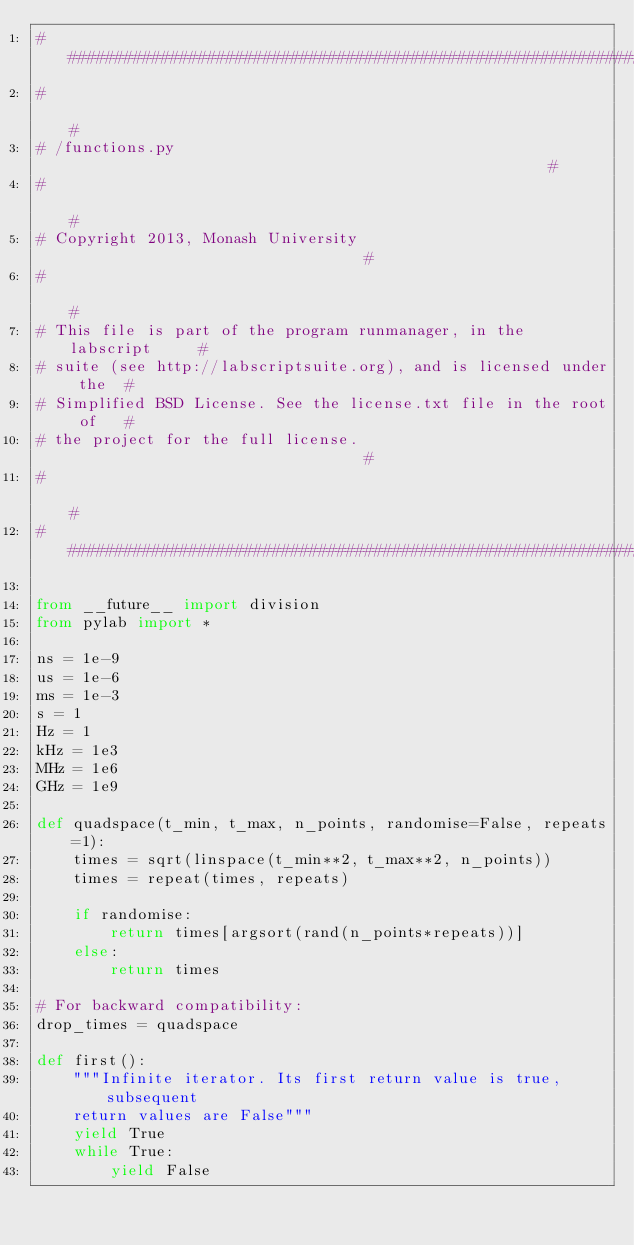Convert code to text. <code><loc_0><loc_0><loc_500><loc_500><_Python_>#####################################################################
#                                                                   #
# /functions.py                                                     #
#                                                                   #
# Copyright 2013, Monash University                                 #
#                                                                   #
# This file is part of the program runmanager, in the labscript     #
# suite (see http://labscriptsuite.org), and is licensed under the  #
# Simplified BSD License. See the license.txt file in the root of   #
# the project for the full license.                                 #
#                                                                   #
#####################################################################

from __future__ import division
from pylab import *

ns = 1e-9
us = 1e-6
ms = 1e-3
s = 1
Hz = 1
kHz = 1e3
MHz = 1e6
GHz = 1e9

def quadspace(t_min, t_max, n_points, randomise=False, repeats=1):
    times = sqrt(linspace(t_min**2, t_max**2, n_points))
    times = repeat(times, repeats)
    
    if randomise:
        return times[argsort(rand(n_points*repeats))]
    else:
        return times
       
# For backward compatibility:
drop_times = quadspace

def first():
    """Infinite iterator. Its first return value is true, subsequent
    return values are False"""
    yield True
    while True:
        yield False
</code> 